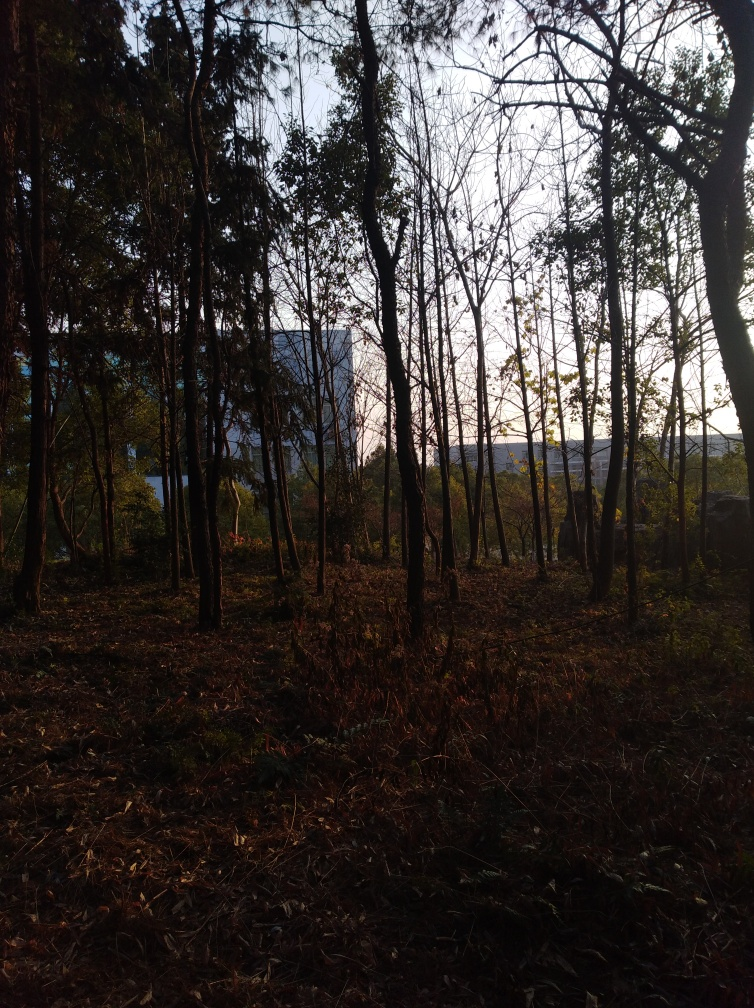Is this a man-made forest or a natural one? It's not possible to determine with absolute certainty whether this forest is man-made or natural from this image alone. However, the relatively uniform spacing between the trees and their similar sizes might hint at the forest being managed or planted by humans. Natural forests typically exhibit a more random dispersion of trees and a greater diversity of tree sizes and species. 